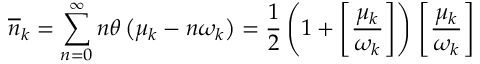Convert formula to latex. <formula><loc_0><loc_0><loc_500><loc_500>\overline { n } _ { k } = \sum _ { n = 0 } ^ { \infty } n \theta \left ( \mu _ { k } - n \omega _ { k } \right ) = \frac { 1 } { 2 } \left ( 1 + \left [ \frac { \mu _ { k } } { \omega _ { k } } \right ] \right ) \, \left [ \frac { \mu _ { k } } { \omega _ { k } } \right ] \,</formula> 